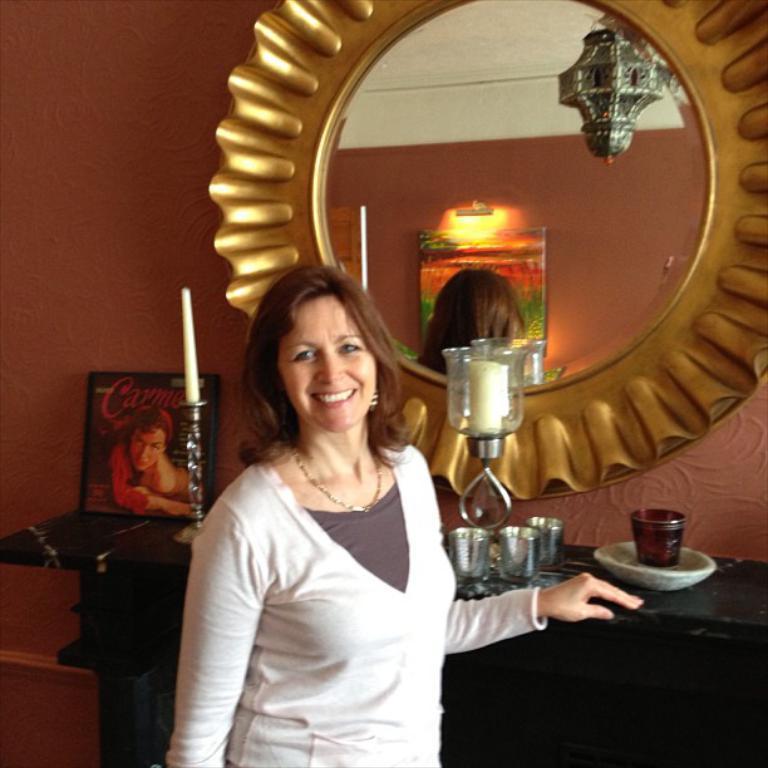Could you give a brief overview of what you see in this image? In this image we can see a woman standing beside a table containing some glasses, a plate, a candle with a stand and a photo frame on it. On the backside we can see a wall and a mirror. We can also see a lamp and a photo frame reflected on the mirror. 